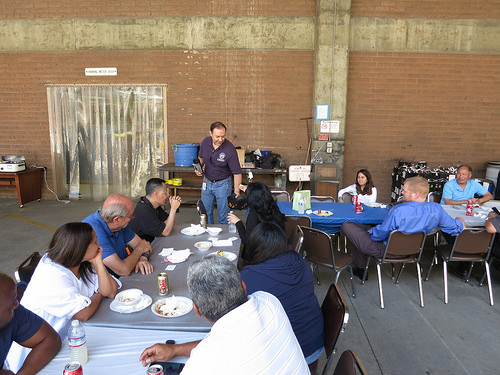<image>
Can you confirm if the shirt is on the person? Yes. Looking at the image, I can see the shirt is positioned on top of the person, with the person providing support. 